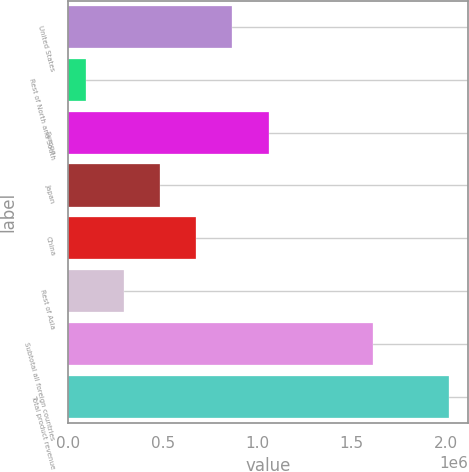<chart> <loc_0><loc_0><loc_500><loc_500><bar_chart><fcel>United States<fcel>Rest of North and South<fcel>Europe<fcel>Japan<fcel>China<fcel>Rest of Asia<fcel>Subtotal all foreign countries<fcel>Total product revenue<nl><fcel>868343<fcel>92954<fcel>1.06054e+06<fcel>483952<fcel>676148<fcel>291757<fcel>1.6133e+06<fcel>2.01491e+06<nl></chart> 